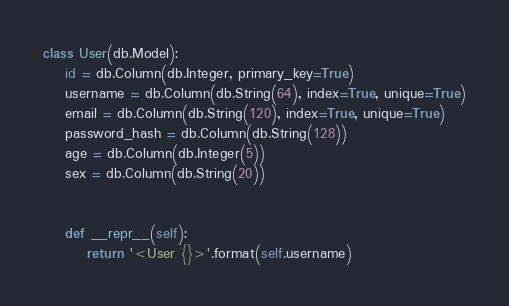<code> <loc_0><loc_0><loc_500><loc_500><_Python_>
class User(db.Model):
    id = db.Column(db.Integer, primary_key=True)
    username = db.Column(db.String(64), index=True, unique=True)
    email = db.Column(db.String(120), index=True, unique=True)
    password_hash = db.Column(db.String(128))
    age = db.Column(db.Integer(5))
    sex = db.Column(db.String(20))


    def __repr__(self):
        return '<User {}>'.format(self.username)  </code> 